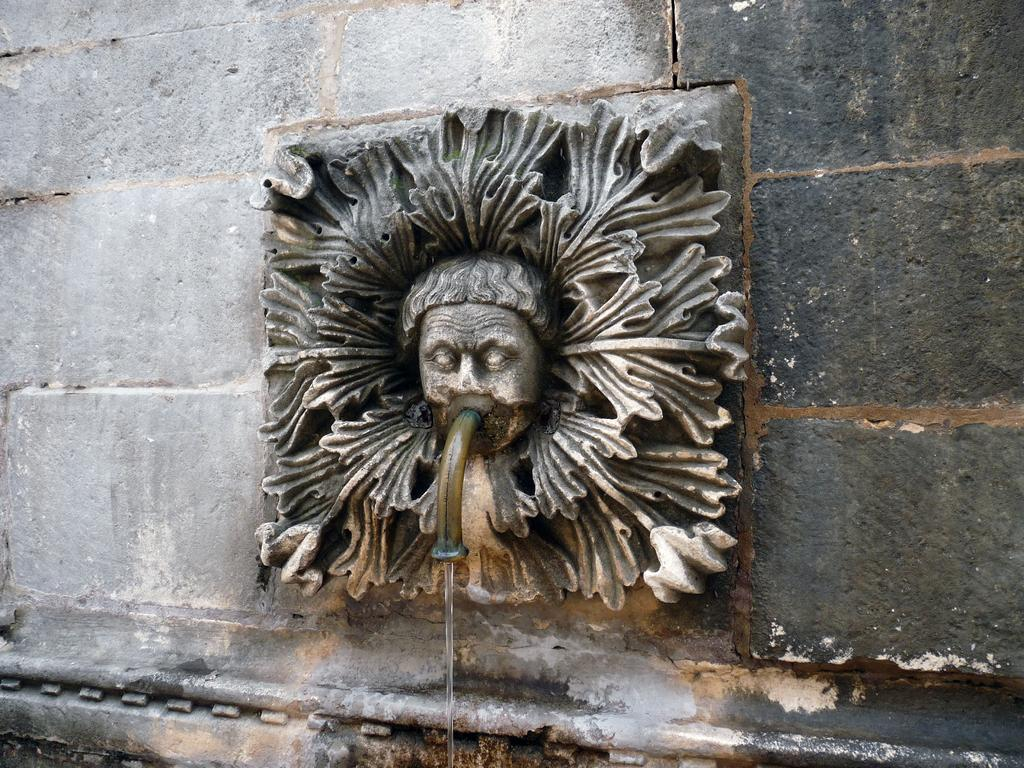What is the main subject of the image? There is a stone carving in the image. What can be seen in the background of the image? There is a wall in the background of the image. What type of object is present in the image that is made of metal? There is a metal pipe in the image. What is the liquid element visible in the image? Water is visible in the image. What type of dress is the person wearing in the image? There is no person present in the image, and therefore no dress can be observed. What type of rake is being used to clean the area in the image? There is no rake present in the image. 